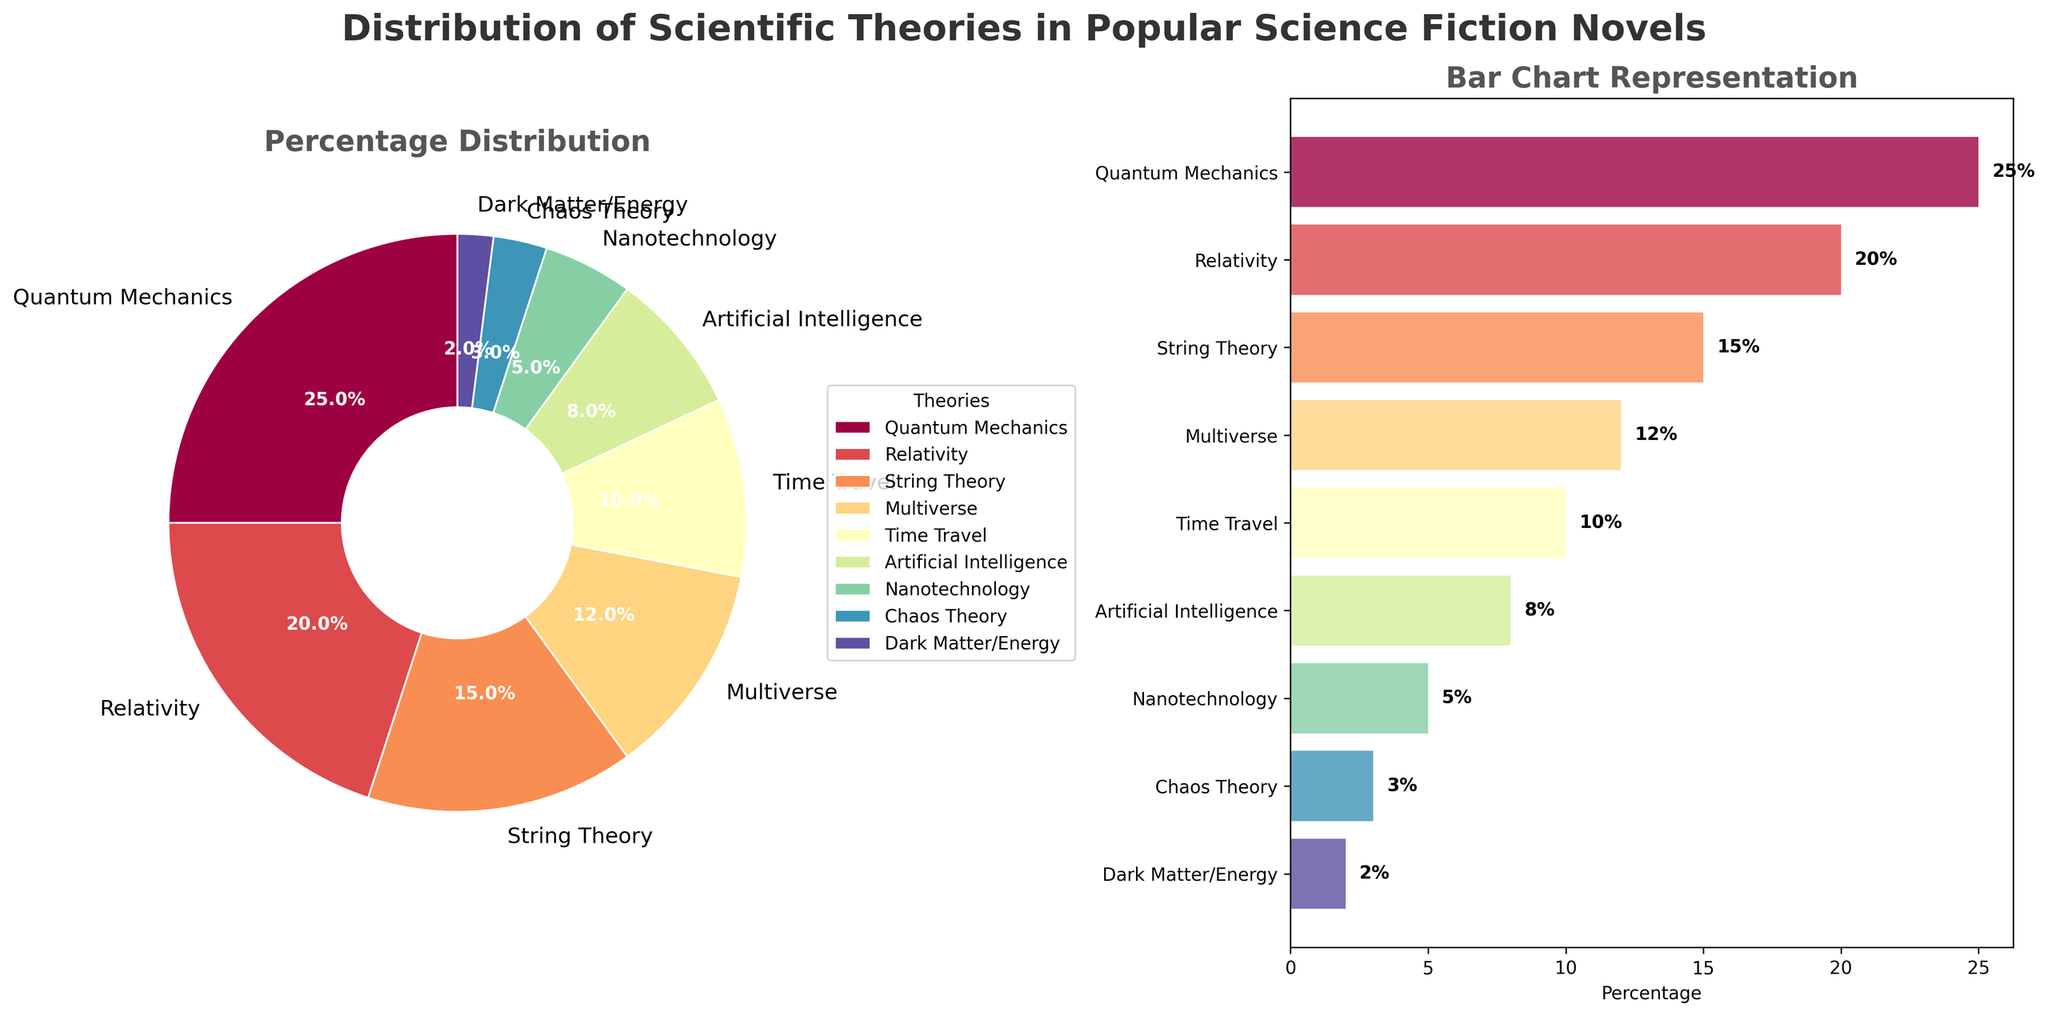What's the most depicted scientific theory in popular science fiction novels? The most depicted theory corresponds to the largest percentage slice in the pie chart and the highest bar in the bar chart. In this case, it is Quantum Mechanics with 25%.
Answer: Quantum Mechanics Which theory is depicted more frequently: Multiverse or Artificial Intelligence? By comparing the percentages from the chart, Multiverse has 12% while Artificial Intelligence has 8%. 12% is greater than 8%.
Answer: Multiverse How much more is the percentage of Relativity compared to Nanotechnology? From the chart, Relativity is depicted at 20% and Nanotechnology at 5%. The difference is 20% - 5% = 15%.
Answer: 15% Which theories have less than 10% representation? The theories with percentages below 10% are Artificial Intelligence (8%), Nanotechnology (5%), Chaos Theory (3%), and Dark Matter/Energy (2%).
Answer: Artificial Intelligence, Nanotechnology, Chaos Theory, Dark Matter/Energy What is the combined percentage of String Theory and Time Travel? String Theory is depicted at 15% and Time Travel at 10%. The combined percentage is 15% + 10% = 25%.
Answer: 25% What visual feature is used to distinguish between different theories in the pie chart? Different sectors in the pie chart are distinguished by various colors, each representing a different theory.
Answer: Colors Which theory has the smallest representation and what percentage does it hold? The theory with the smallest representation has the smallest slice in the pie chart and the smallest bar in the bar chart. Dark Matter/Energy holds 2%.
Answer: Dark Matter/Energy, 2% How does the representation of Chaos Theory compare to Time Travel? Chaos Theory is represented by a 3% slice and bar, whereas Time Travel is at 10%. Thus, Time Travel has a higher percentage than Chaos Theory.
Answer: Time Travel is higher Sum the percentages of all the theories depicted in the chart. Adding all the percentages together: 25% (Quantum Mechanics) + 20% (Relativity) + 15% (String Theory) + 12% (Multiverse) + 10% (Time Travel) + 8% (Artificial Intelligence) + 5% (Nanotechnology) + 3% (Chaos Theory) + 2% (Dark Matter/Energy) = 100%.
Answer: 100% Which theory occupies the least area in the bar chart? The theory with the smallest bar (least area) in the bar chart represents the smallest percentage, which is Dark Matter/Energy at 2%.
Answer: Dark Matter/Energy 